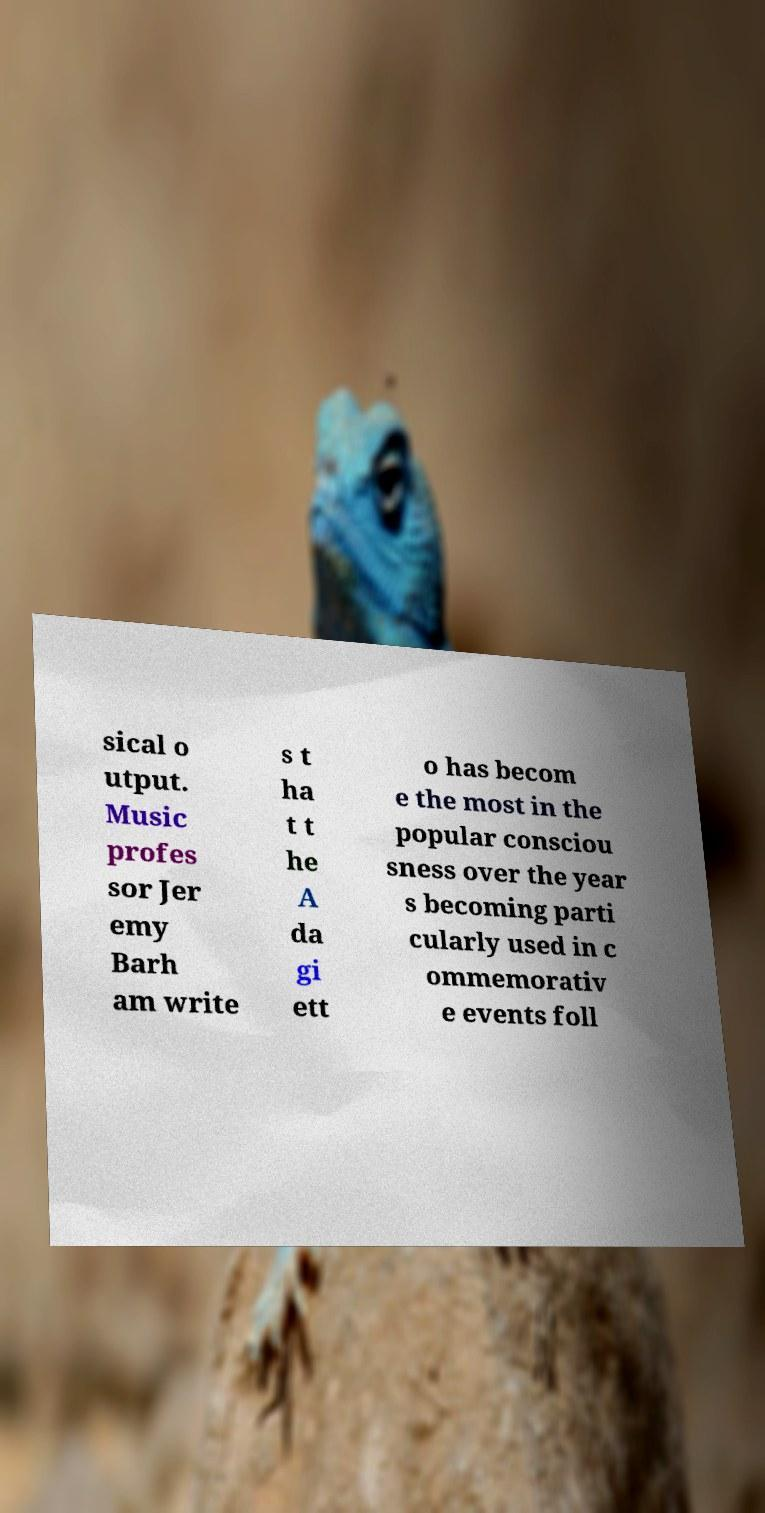What messages or text are displayed in this image? I need them in a readable, typed format. sical o utput. Music profes sor Jer emy Barh am write s t ha t t he A da gi ett o has becom e the most in the popular consciou sness over the year s becoming parti cularly used in c ommemorativ e events foll 